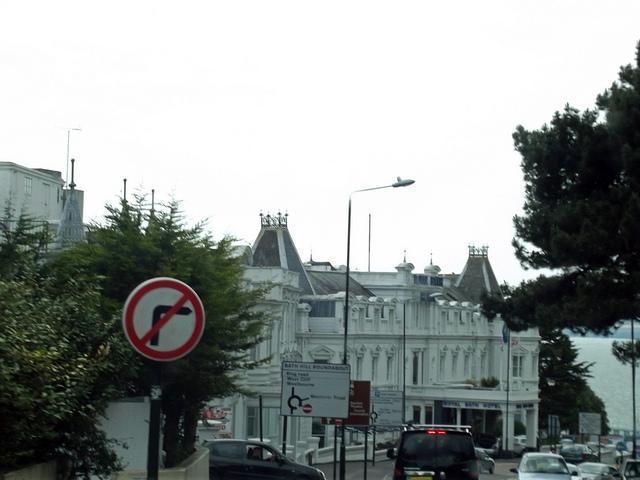What pedal does the driver of the black van have their foot on?
From the following set of four choices, select the accurate answer to respond to the question.
Options: Brake, accelerator, none, fast forward. Brake. 